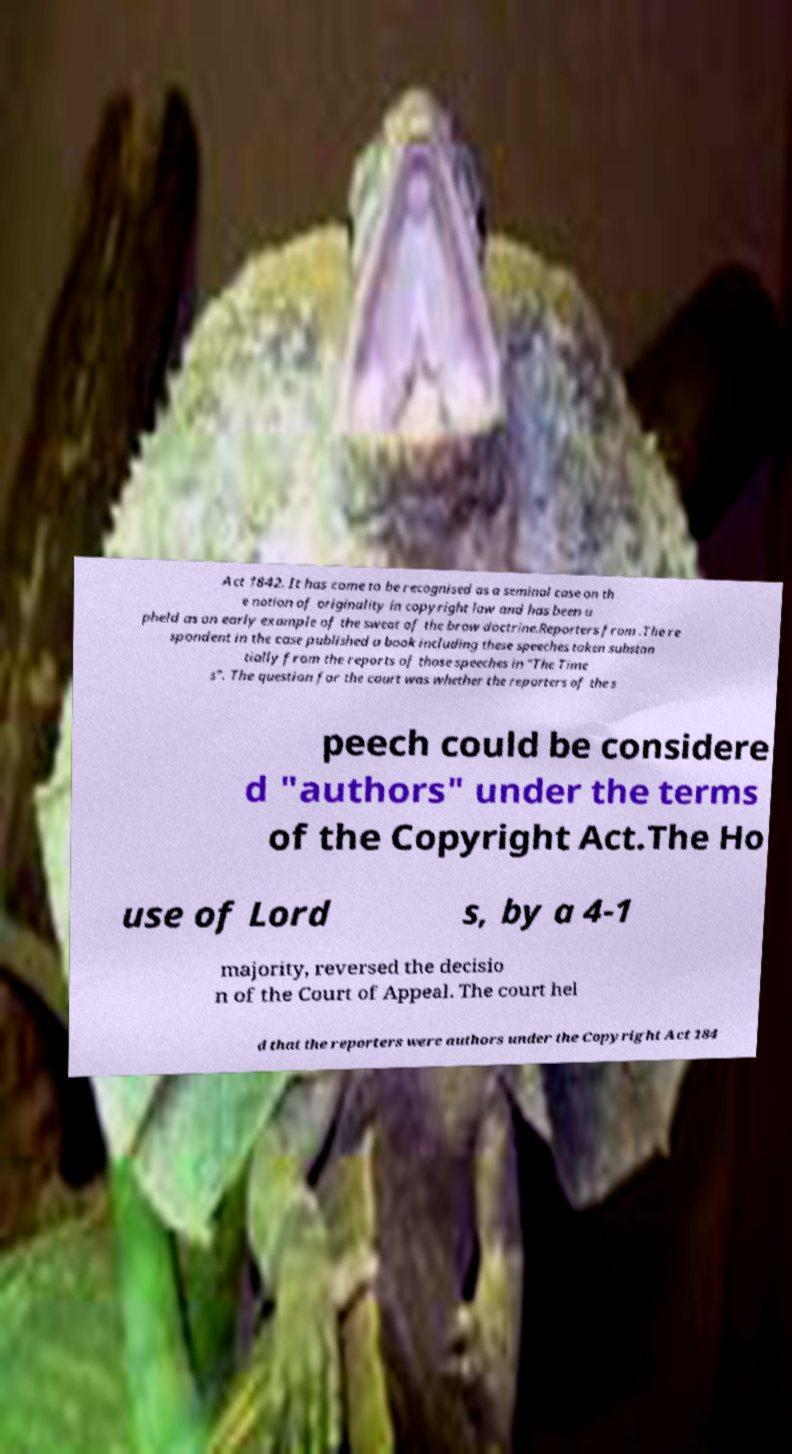What messages or text are displayed in this image? I need them in a readable, typed format. Act 1842. It has come to be recognised as a seminal case on th e notion of originality in copyright law and has been u pheld as an early example of the sweat of the brow doctrine.Reporters from .The re spondent in the case published a book including these speeches taken substan tially from the reports of those speeches in "The Time s". The question for the court was whether the reporters of the s peech could be considere d "authors" under the terms of the Copyright Act.The Ho use of Lord s, by a 4-1 majority, reversed the decisio n of the Court of Appeal. The court hel d that the reporters were authors under the Copyright Act 184 